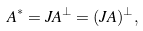<formula> <loc_0><loc_0><loc_500><loc_500>A ^ { * } = J A ^ { \perp } = ( J A ) ^ { \perp } ,</formula> 